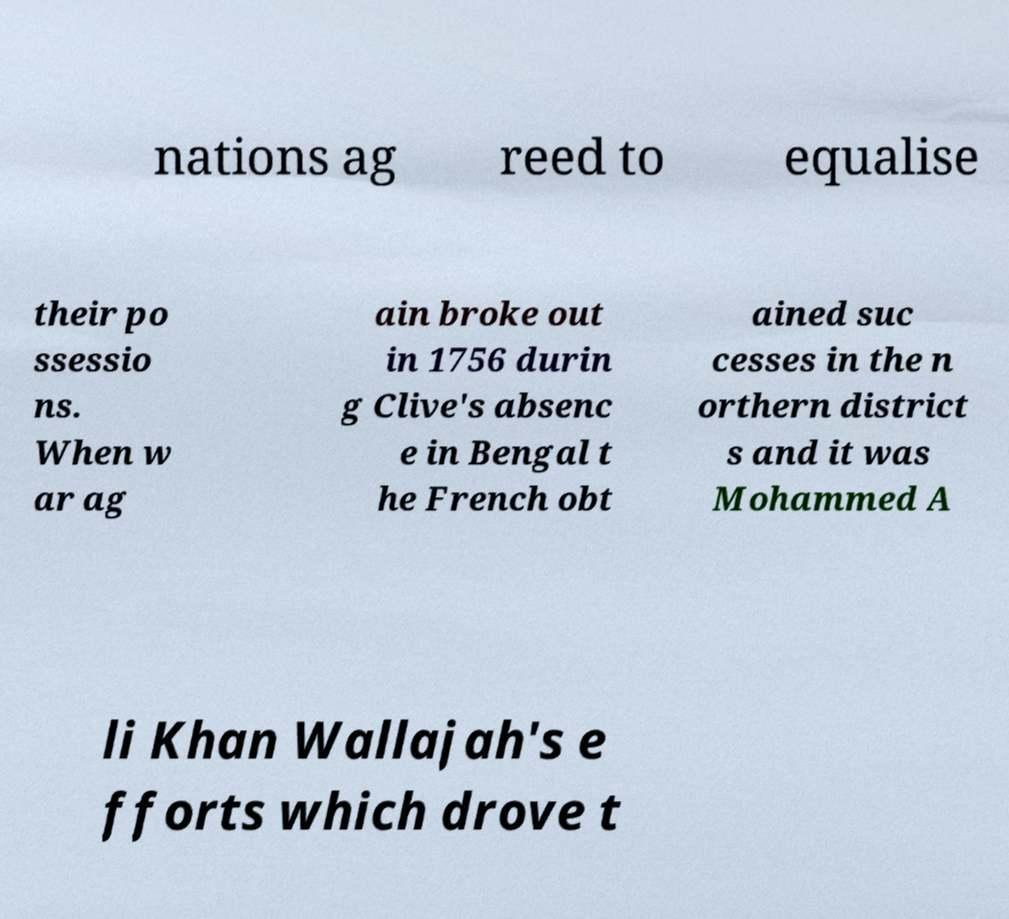Can you accurately transcribe the text from the provided image for me? nations ag reed to equalise their po ssessio ns. When w ar ag ain broke out in 1756 durin g Clive's absenc e in Bengal t he French obt ained suc cesses in the n orthern district s and it was Mohammed A li Khan Wallajah's e fforts which drove t 